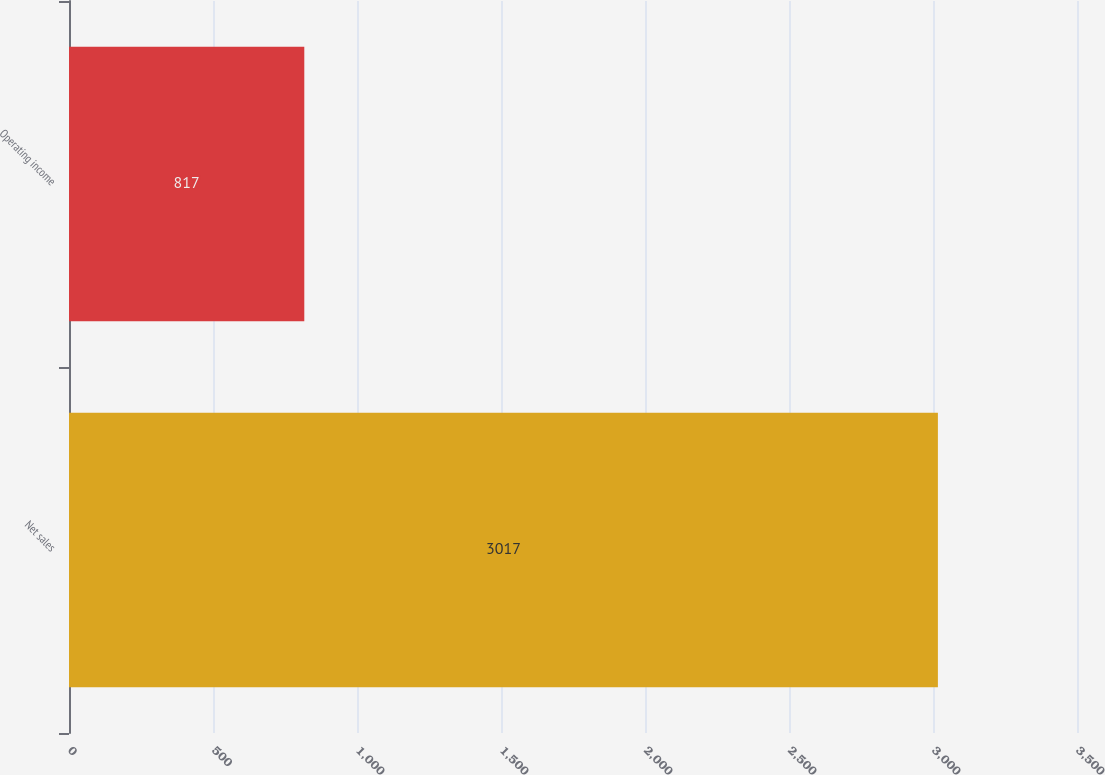<chart> <loc_0><loc_0><loc_500><loc_500><bar_chart><fcel>Net sales<fcel>Operating income<nl><fcel>3017<fcel>817<nl></chart> 